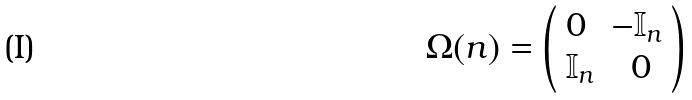<formula> <loc_0><loc_0><loc_500><loc_500>\Omega ( n ) = \left ( \begin{array} { l l } 0 & - \mathbb { I } _ { n } \\ \mathbb { I } _ { n } & \ \ 0 \end{array} \right )</formula> 